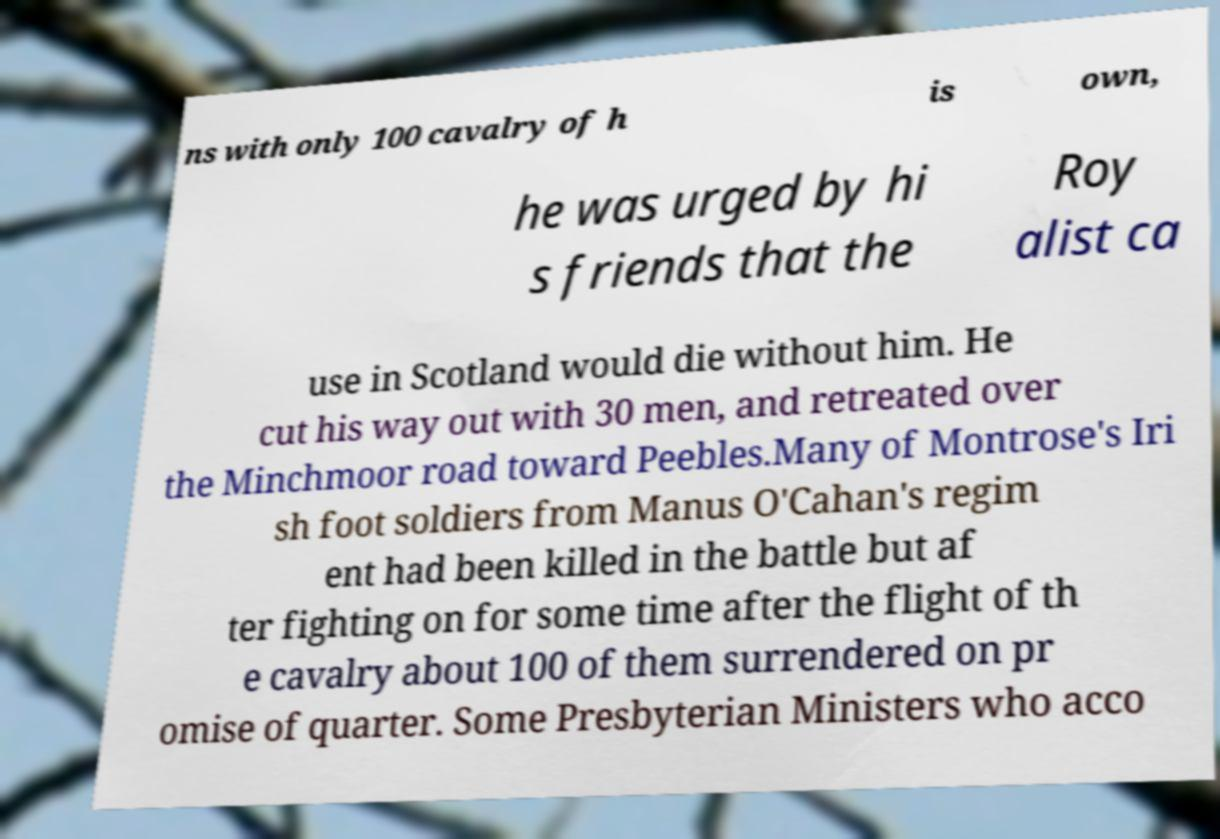For documentation purposes, I need the text within this image transcribed. Could you provide that? ns with only 100 cavalry of h is own, he was urged by hi s friends that the Roy alist ca use in Scotland would die without him. He cut his way out with 30 men, and retreated over the Minchmoor road toward Peebles.Many of Montrose's Iri sh foot soldiers from Manus O'Cahan's regim ent had been killed in the battle but af ter fighting on for some time after the flight of th e cavalry about 100 of them surrendered on pr omise of quarter. Some Presbyterian Ministers who acco 